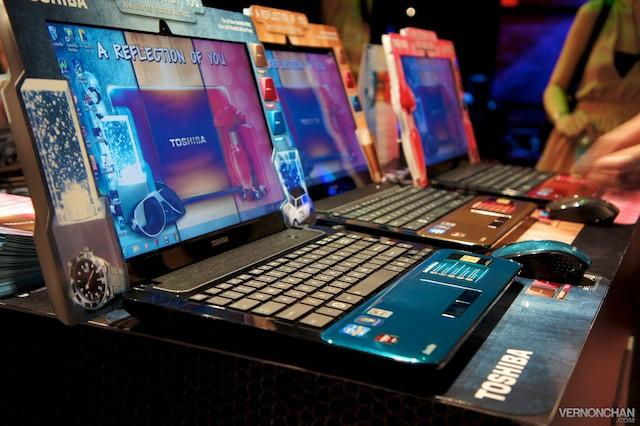What kind of label is on the desk?

Choices:
A) instructional
B) directional
C) brand
D) regulatory brand 